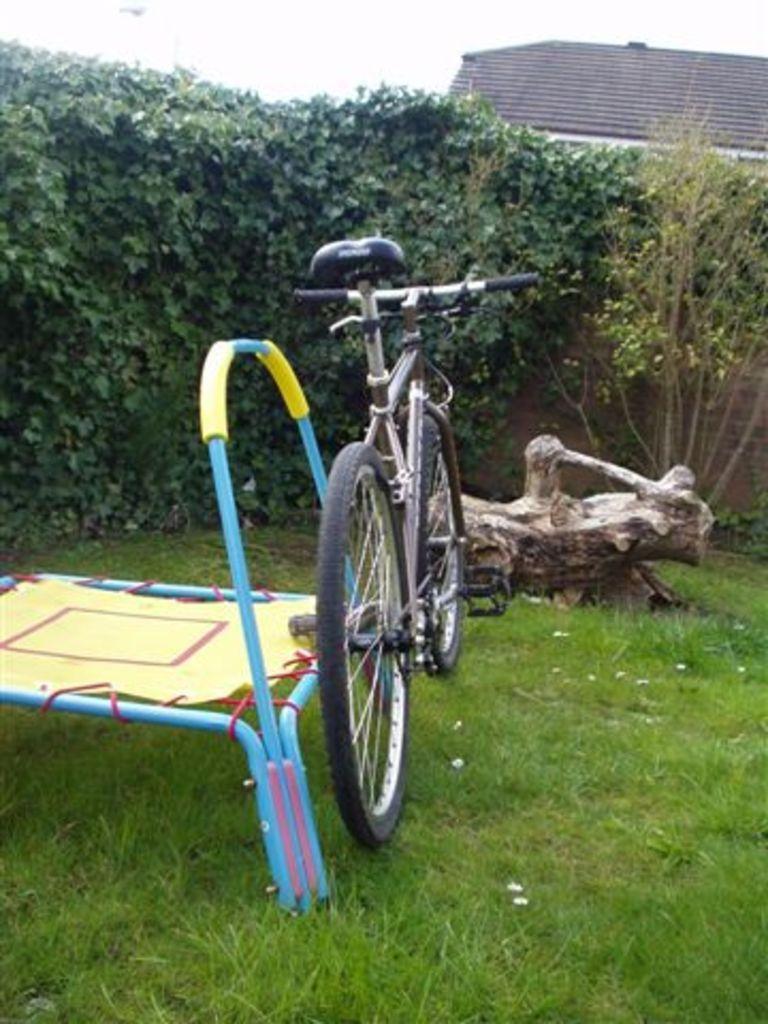How would you summarize this image in a sentence or two? In the image there is a cycle kept on a grass surface and in front of the cycle there is a wooden log and in front of the wooden log there are some plants and a tree, behind the tree there is a roof and there is some object kept beside the cycle on the left side. 